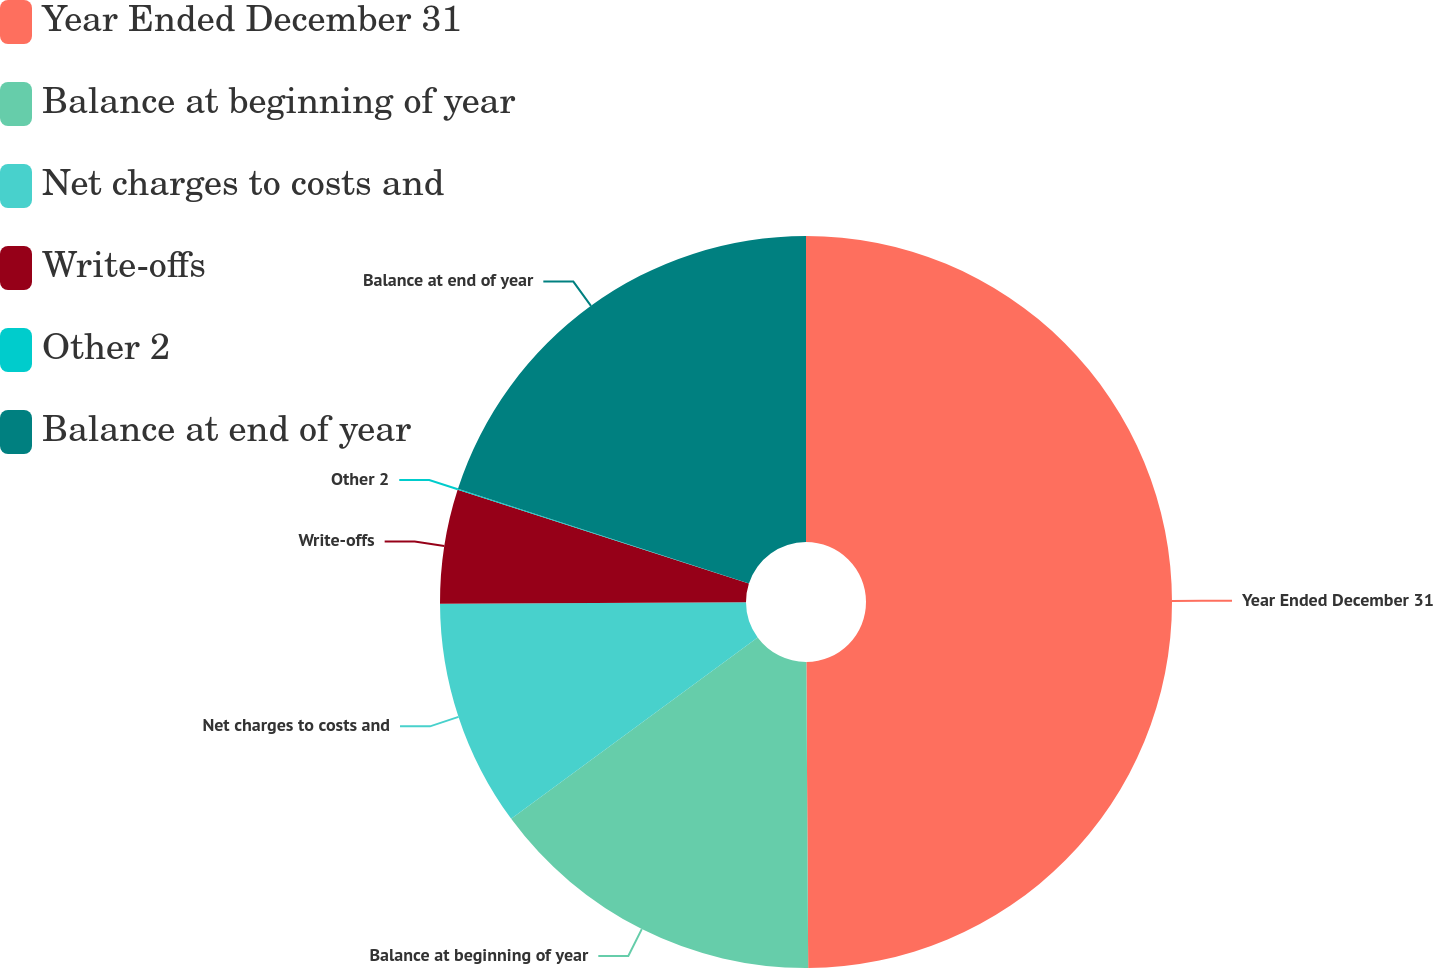Convert chart to OTSL. <chart><loc_0><loc_0><loc_500><loc_500><pie_chart><fcel>Year Ended December 31<fcel>Balance at beginning of year<fcel>Net charges to costs and<fcel>Write-offs<fcel>Other 2<fcel>Balance at end of year<nl><fcel>49.9%<fcel>15.0%<fcel>10.02%<fcel>5.03%<fcel>0.05%<fcel>19.99%<nl></chart> 